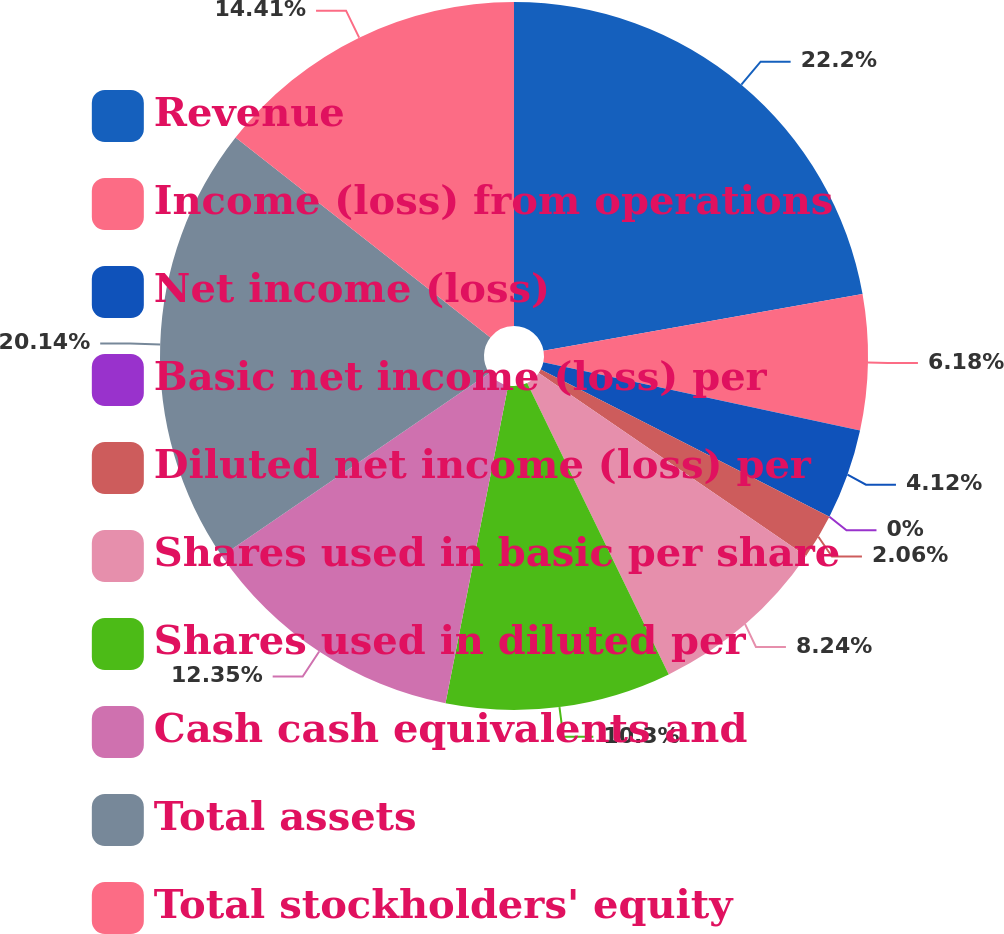Convert chart. <chart><loc_0><loc_0><loc_500><loc_500><pie_chart><fcel>Revenue<fcel>Income (loss) from operations<fcel>Net income (loss)<fcel>Basic net income (loss) per<fcel>Diluted net income (loss) per<fcel>Shares used in basic per share<fcel>Shares used in diluted per<fcel>Cash cash equivalents and<fcel>Total assets<fcel>Total stockholders' equity<nl><fcel>22.2%<fcel>6.18%<fcel>4.12%<fcel>0.0%<fcel>2.06%<fcel>8.24%<fcel>10.3%<fcel>12.35%<fcel>20.14%<fcel>14.41%<nl></chart> 